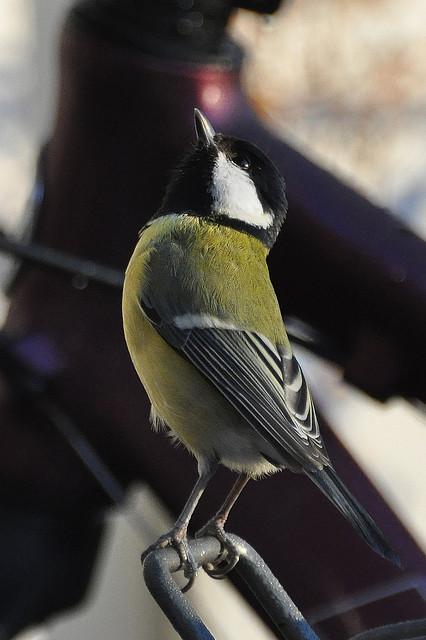Is this a large bird?
Quick response, please. No. What color is the bird?
Short answer required. Green, black and white. What is the bird standing on?
Keep it brief. Metal. 